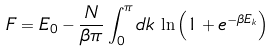<formula> <loc_0><loc_0><loc_500><loc_500>F = E _ { 0 } - \frac { N } { \beta \pi } \int _ { 0 } ^ { \pi } d k \, \ln \left ( 1 + e ^ { - \beta E _ { k } } \right )</formula> 